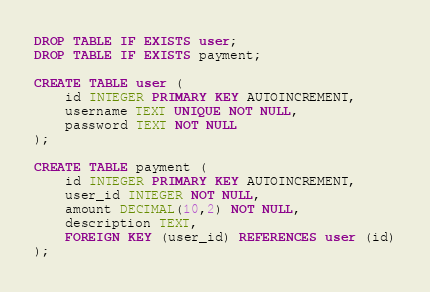<code> <loc_0><loc_0><loc_500><loc_500><_SQL_>DROP TABLE IF EXISTS user;
DROP TABLE IF EXISTS payment;

CREATE TABLE user (
    id INTEGER PRIMARY KEY AUTOINCREMENT,
    username TEXT UNIQUE NOT NULL,
    password TEXT NOT NULL
);

CREATE TABLE payment (
    id INTEGER PRIMARY KEY AUTOINCREMENT,
    user_id INTEGER NOT NULL,
    amount DECIMAL(10,2) NOT NULL,
    description TEXT,
    FOREIGN KEY (user_id) REFERENCES user (id)
);
</code> 